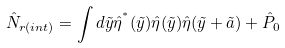<formula> <loc_0><loc_0><loc_500><loc_500>\hat { N } _ { r ( i n t ) } = \int d \tilde { y } \hat { \eta } ^ { ^ { * } } ( \tilde { y } ) \hat { \eta } ( \tilde { y } ) \hat { \eta } ( \tilde { y } + \tilde { a } ) + \hat { P } _ { 0 }</formula> 